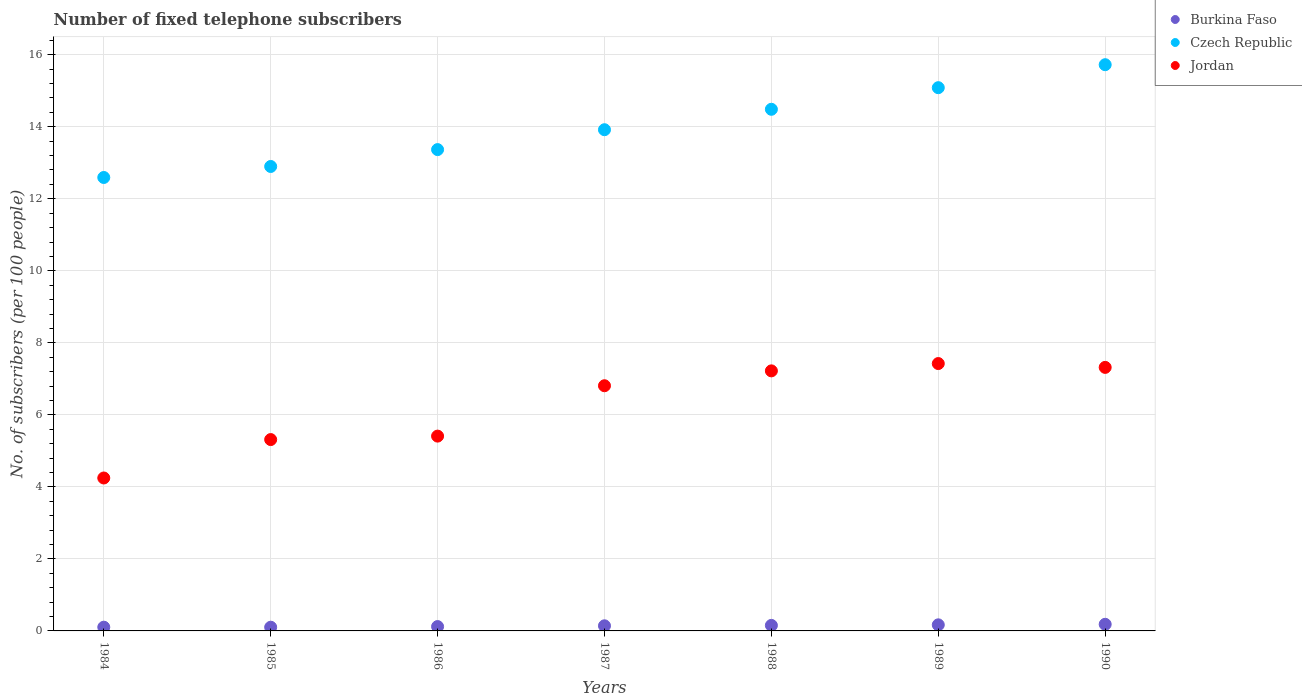How many different coloured dotlines are there?
Your answer should be compact. 3. Is the number of dotlines equal to the number of legend labels?
Your answer should be compact. Yes. What is the number of fixed telephone subscribers in Czech Republic in 1985?
Make the answer very short. 12.9. Across all years, what is the maximum number of fixed telephone subscribers in Czech Republic?
Give a very brief answer. 15.72. Across all years, what is the minimum number of fixed telephone subscribers in Jordan?
Provide a succinct answer. 4.25. In which year was the number of fixed telephone subscribers in Czech Republic maximum?
Your answer should be very brief. 1990. What is the total number of fixed telephone subscribers in Jordan in the graph?
Offer a very short reply. 43.74. What is the difference between the number of fixed telephone subscribers in Czech Republic in 1985 and that in 1989?
Provide a short and direct response. -2.19. What is the difference between the number of fixed telephone subscribers in Czech Republic in 1988 and the number of fixed telephone subscribers in Jordan in 1987?
Offer a very short reply. 7.68. What is the average number of fixed telephone subscribers in Burkina Faso per year?
Keep it short and to the point. 0.14. In the year 1990, what is the difference between the number of fixed telephone subscribers in Jordan and number of fixed telephone subscribers in Czech Republic?
Offer a very short reply. -8.41. What is the ratio of the number of fixed telephone subscribers in Burkina Faso in 1989 to that in 1990?
Offer a terse response. 0.92. What is the difference between the highest and the second highest number of fixed telephone subscribers in Jordan?
Provide a succinct answer. 0.11. What is the difference between the highest and the lowest number of fixed telephone subscribers in Czech Republic?
Your answer should be very brief. 3.13. Is the number of fixed telephone subscribers in Burkina Faso strictly greater than the number of fixed telephone subscribers in Jordan over the years?
Make the answer very short. No. How many dotlines are there?
Your answer should be compact. 3. How many years are there in the graph?
Offer a terse response. 7. Does the graph contain any zero values?
Your response must be concise. No. Where does the legend appear in the graph?
Your answer should be compact. Top right. What is the title of the graph?
Your response must be concise. Number of fixed telephone subscribers. What is the label or title of the Y-axis?
Your answer should be compact. No. of subscribers (per 100 people). What is the No. of subscribers (per 100 people) in Burkina Faso in 1984?
Provide a short and direct response. 0.1. What is the No. of subscribers (per 100 people) in Czech Republic in 1984?
Offer a very short reply. 12.59. What is the No. of subscribers (per 100 people) in Jordan in 1984?
Ensure brevity in your answer.  4.25. What is the No. of subscribers (per 100 people) of Burkina Faso in 1985?
Make the answer very short. 0.1. What is the No. of subscribers (per 100 people) of Czech Republic in 1985?
Provide a succinct answer. 12.9. What is the No. of subscribers (per 100 people) in Jordan in 1985?
Provide a succinct answer. 5.31. What is the No. of subscribers (per 100 people) in Burkina Faso in 1986?
Give a very brief answer. 0.12. What is the No. of subscribers (per 100 people) of Czech Republic in 1986?
Your answer should be very brief. 13.37. What is the No. of subscribers (per 100 people) of Jordan in 1986?
Ensure brevity in your answer.  5.41. What is the No. of subscribers (per 100 people) in Burkina Faso in 1987?
Your response must be concise. 0.14. What is the No. of subscribers (per 100 people) in Czech Republic in 1987?
Your answer should be very brief. 13.92. What is the No. of subscribers (per 100 people) in Jordan in 1987?
Your answer should be compact. 6.81. What is the No. of subscribers (per 100 people) in Burkina Faso in 1988?
Your response must be concise. 0.15. What is the No. of subscribers (per 100 people) of Czech Republic in 1988?
Ensure brevity in your answer.  14.49. What is the No. of subscribers (per 100 people) in Jordan in 1988?
Keep it short and to the point. 7.22. What is the No. of subscribers (per 100 people) of Burkina Faso in 1989?
Make the answer very short. 0.17. What is the No. of subscribers (per 100 people) in Czech Republic in 1989?
Your answer should be very brief. 15.09. What is the No. of subscribers (per 100 people) in Jordan in 1989?
Your answer should be compact. 7.42. What is the No. of subscribers (per 100 people) of Burkina Faso in 1990?
Your response must be concise. 0.18. What is the No. of subscribers (per 100 people) in Czech Republic in 1990?
Provide a succinct answer. 15.72. What is the No. of subscribers (per 100 people) in Jordan in 1990?
Offer a terse response. 7.32. Across all years, what is the maximum No. of subscribers (per 100 people) in Burkina Faso?
Keep it short and to the point. 0.18. Across all years, what is the maximum No. of subscribers (per 100 people) of Czech Republic?
Make the answer very short. 15.72. Across all years, what is the maximum No. of subscribers (per 100 people) in Jordan?
Ensure brevity in your answer.  7.42. Across all years, what is the minimum No. of subscribers (per 100 people) in Burkina Faso?
Make the answer very short. 0.1. Across all years, what is the minimum No. of subscribers (per 100 people) of Czech Republic?
Give a very brief answer. 12.59. Across all years, what is the minimum No. of subscribers (per 100 people) in Jordan?
Ensure brevity in your answer.  4.25. What is the total No. of subscribers (per 100 people) in Czech Republic in the graph?
Your response must be concise. 98.07. What is the total No. of subscribers (per 100 people) of Jordan in the graph?
Keep it short and to the point. 43.74. What is the difference between the No. of subscribers (per 100 people) of Burkina Faso in 1984 and that in 1985?
Offer a very short reply. 0. What is the difference between the No. of subscribers (per 100 people) in Czech Republic in 1984 and that in 1985?
Your answer should be compact. -0.31. What is the difference between the No. of subscribers (per 100 people) in Jordan in 1984 and that in 1985?
Provide a short and direct response. -1.07. What is the difference between the No. of subscribers (per 100 people) in Burkina Faso in 1984 and that in 1986?
Give a very brief answer. -0.02. What is the difference between the No. of subscribers (per 100 people) in Czech Republic in 1984 and that in 1986?
Provide a succinct answer. -0.77. What is the difference between the No. of subscribers (per 100 people) in Jordan in 1984 and that in 1986?
Give a very brief answer. -1.16. What is the difference between the No. of subscribers (per 100 people) of Burkina Faso in 1984 and that in 1987?
Make the answer very short. -0.04. What is the difference between the No. of subscribers (per 100 people) of Czech Republic in 1984 and that in 1987?
Offer a terse response. -1.33. What is the difference between the No. of subscribers (per 100 people) in Jordan in 1984 and that in 1987?
Your response must be concise. -2.56. What is the difference between the No. of subscribers (per 100 people) in Burkina Faso in 1984 and that in 1988?
Provide a short and direct response. -0.05. What is the difference between the No. of subscribers (per 100 people) of Czech Republic in 1984 and that in 1988?
Provide a succinct answer. -1.89. What is the difference between the No. of subscribers (per 100 people) of Jordan in 1984 and that in 1988?
Your response must be concise. -2.97. What is the difference between the No. of subscribers (per 100 people) in Burkina Faso in 1984 and that in 1989?
Your answer should be very brief. -0.07. What is the difference between the No. of subscribers (per 100 people) in Czech Republic in 1984 and that in 1989?
Offer a terse response. -2.49. What is the difference between the No. of subscribers (per 100 people) of Jordan in 1984 and that in 1989?
Ensure brevity in your answer.  -3.18. What is the difference between the No. of subscribers (per 100 people) of Burkina Faso in 1984 and that in 1990?
Provide a short and direct response. -0.08. What is the difference between the No. of subscribers (per 100 people) in Czech Republic in 1984 and that in 1990?
Offer a very short reply. -3.13. What is the difference between the No. of subscribers (per 100 people) in Jordan in 1984 and that in 1990?
Your answer should be very brief. -3.07. What is the difference between the No. of subscribers (per 100 people) in Burkina Faso in 1985 and that in 1986?
Offer a terse response. -0.02. What is the difference between the No. of subscribers (per 100 people) of Czech Republic in 1985 and that in 1986?
Offer a very short reply. -0.47. What is the difference between the No. of subscribers (per 100 people) in Jordan in 1985 and that in 1986?
Provide a short and direct response. -0.1. What is the difference between the No. of subscribers (per 100 people) of Burkina Faso in 1985 and that in 1987?
Provide a succinct answer. -0.04. What is the difference between the No. of subscribers (per 100 people) of Czech Republic in 1985 and that in 1987?
Your answer should be very brief. -1.02. What is the difference between the No. of subscribers (per 100 people) of Jordan in 1985 and that in 1987?
Provide a short and direct response. -1.5. What is the difference between the No. of subscribers (per 100 people) of Burkina Faso in 1985 and that in 1988?
Provide a short and direct response. -0.05. What is the difference between the No. of subscribers (per 100 people) of Czech Republic in 1985 and that in 1988?
Give a very brief answer. -1.59. What is the difference between the No. of subscribers (per 100 people) in Jordan in 1985 and that in 1988?
Keep it short and to the point. -1.91. What is the difference between the No. of subscribers (per 100 people) in Burkina Faso in 1985 and that in 1989?
Your answer should be very brief. -0.07. What is the difference between the No. of subscribers (per 100 people) of Czech Republic in 1985 and that in 1989?
Make the answer very short. -2.19. What is the difference between the No. of subscribers (per 100 people) in Jordan in 1985 and that in 1989?
Make the answer very short. -2.11. What is the difference between the No. of subscribers (per 100 people) of Burkina Faso in 1985 and that in 1990?
Ensure brevity in your answer.  -0.08. What is the difference between the No. of subscribers (per 100 people) in Czech Republic in 1985 and that in 1990?
Your response must be concise. -2.83. What is the difference between the No. of subscribers (per 100 people) of Jordan in 1985 and that in 1990?
Offer a very short reply. -2. What is the difference between the No. of subscribers (per 100 people) of Burkina Faso in 1986 and that in 1987?
Your response must be concise. -0.02. What is the difference between the No. of subscribers (per 100 people) in Czech Republic in 1986 and that in 1987?
Your answer should be very brief. -0.55. What is the difference between the No. of subscribers (per 100 people) in Jordan in 1986 and that in 1987?
Provide a short and direct response. -1.4. What is the difference between the No. of subscribers (per 100 people) in Burkina Faso in 1986 and that in 1988?
Give a very brief answer. -0.03. What is the difference between the No. of subscribers (per 100 people) of Czech Republic in 1986 and that in 1988?
Your answer should be compact. -1.12. What is the difference between the No. of subscribers (per 100 people) in Jordan in 1986 and that in 1988?
Provide a succinct answer. -1.81. What is the difference between the No. of subscribers (per 100 people) of Burkina Faso in 1986 and that in 1989?
Offer a terse response. -0.05. What is the difference between the No. of subscribers (per 100 people) of Czech Republic in 1986 and that in 1989?
Your response must be concise. -1.72. What is the difference between the No. of subscribers (per 100 people) of Jordan in 1986 and that in 1989?
Keep it short and to the point. -2.01. What is the difference between the No. of subscribers (per 100 people) in Burkina Faso in 1986 and that in 1990?
Give a very brief answer. -0.06. What is the difference between the No. of subscribers (per 100 people) in Czech Republic in 1986 and that in 1990?
Provide a succinct answer. -2.36. What is the difference between the No. of subscribers (per 100 people) of Jordan in 1986 and that in 1990?
Offer a very short reply. -1.91. What is the difference between the No. of subscribers (per 100 people) of Burkina Faso in 1987 and that in 1988?
Ensure brevity in your answer.  -0.01. What is the difference between the No. of subscribers (per 100 people) in Czech Republic in 1987 and that in 1988?
Ensure brevity in your answer.  -0.57. What is the difference between the No. of subscribers (per 100 people) in Jordan in 1987 and that in 1988?
Your answer should be compact. -0.41. What is the difference between the No. of subscribers (per 100 people) of Burkina Faso in 1987 and that in 1989?
Provide a succinct answer. -0.03. What is the difference between the No. of subscribers (per 100 people) in Czech Republic in 1987 and that in 1989?
Your response must be concise. -1.17. What is the difference between the No. of subscribers (per 100 people) in Jordan in 1987 and that in 1989?
Ensure brevity in your answer.  -0.62. What is the difference between the No. of subscribers (per 100 people) in Burkina Faso in 1987 and that in 1990?
Offer a very short reply. -0.04. What is the difference between the No. of subscribers (per 100 people) of Czech Republic in 1987 and that in 1990?
Give a very brief answer. -1.81. What is the difference between the No. of subscribers (per 100 people) in Jordan in 1987 and that in 1990?
Give a very brief answer. -0.51. What is the difference between the No. of subscribers (per 100 people) in Burkina Faso in 1988 and that in 1989?
Your answer should be compact. -0.02. What is the difference between the No. of subscribers (per 100 people) of Jordan in 1988 and that in 1989?
Your answer should be very brief. -0.2. What is the difference between the No. of subscribers (per 100 people) of Burkina Faso in 1988 and that in 1990?
Your answer should be compact. -0.03. What is the difference between the No. of subscribers (per 100 people) in Czech Republic in 1988 and that in 1990?
Your answer should be very brief. -1.24. What is the difference between the No. of subscribers (per 100 people) of Jordan in 1988 and that in 1990?
Provide a short and direct response. -0.1. What is the difference between the No. of subscribers (per 100 people) of Burkina Faso in 1989 and that in 1990?
Give a very brief answer. -0.01. What is the difference between the No. of subscribers (per 100 people) of Czech Republic in 1989 and that in 1990?
Offer a terse response. -0.64. What is the difference between the No. of subscribers (per 100 people) in Jordan in 1989 and that in 1990?
Make the answer very short. 0.11. What is the difference between the No. of subscribers (per 100 people) of Burkina Faso in 1984 and the No. of subscribers (per 100 people) of Czech Republic in 1985?
Your response must be concise. -12.79. What is the difference between the No. of subscribers (per 100 people) in Burkina Faso in 1984 and the No. of subscribers (per 100 people) in Jordan in 1985?
Provide a short and direct response. -5.21. What is the difference between the No. of subscribers (per 100 people) in Czech Republic in 1984 and the No. of subscribers (per 100 people) in Jordan in 1985?
Keep it short and to the point. 7.28. What is the difference between the No. of subscribers (per 100 people) of Burkina Faso in 1984 and the No. of subscribers (per 100 people) of Czech Republic in 1986?
Offer a terse response. -13.26. What is the difference between the No. of subscribers (per 100 people) of Burkina Faso in 1984 and the No. of subscribers (per 100 people) of Jordan in 1986?
Offer a terse response. -5.31. What is the difference between the No. of subscribers (per 100 people) of Czech Republic in 1984 and the No. of subscribers (per 100 people) of Jordan in 1986?
Give a very brief answer. 7.18. What is the difference between the No. of subscribers (per 100 people) of Burkina Faso in 1984 and the No. of subscribers (per 100 people) of Czech Republic in 1987?
Make the answer very short. -13.81. What is the difference between the No. of subscribers (per 100 people) of Burkina Faso in 1984 and the No. of subscribers (per 100 people) of Jordan in 1987?
Ensure brevity in your answer.  -6.71. What is the difference between the No. of subscribers (per 100 people) of Czech Republic in 1984 and the No. of subscribers (per 100 people) of Jordan in 1987?
Your response must be concise. 5.78. What is the difference between the No. of subscribers (per 100 people) of Burkina Faso in 1984 and the No. of subscribers (per 100 people) of Czech Republic in 1988?
Provide a short and direct response. -14.38. What is the difference between the No. of subscribers (per 100 people) in Burkina Faso in 1984 and the No. of subscribers (per 100 people) in Jordan in 1988?
Ensure brevity in your answer.  -7.12. What is the difference between the No. of subscribers (per 100 people) in Czech Republic in 1984 and the No. of subscribers (per 100 people) in Jordan in 1988?
Your answer should be very brief. 5.37. What is the difference between the No. of subscribers (per 100 people) in Burkina Faso in 1984 and the No. of subscribers (per 100 people) in Czech Republic in 1989?
Your answer should be compact. -14.98. What is the difference between the No. of subscribers (per 100 people) in Burkina Faso in 1984 and the No. of subscribers (per 100 people) in Jordan in 1989?
Make the answer very short. -7.32. What is the difference between the No. of subscribers (per 100 people) of Czech Republic in 1984 and the No. of subscribers (per 100 people) of Jordan in 1989?
Give a very brief answer. 5.17. What is the difference between the No. of subscribers (per 100 people) of Burkina Faso in 1984 and the No. of subscribers (per 100 people) of Czech Republic in 1990?
Make the answer very short. -15.62. What is the difference between the No. of subscribers (per 100 people) in Burkina Faso in 1984 and the No. of subscribers (per 100 people) in Jordan in 1990?
Offer a terse response. -7.21. What is the difference between the No. of subscribers (per 100 people) in Czech Republic in 1984 and the No. of subscribers (per 100 people) in Jordan in 1990?
Offer a very short reply. 5.27. What is the difference between the No. of subscribers (per 100 people) of Burkina Faso in 1985 and the No. of subscribers (per 100 people) of Czech Republic in 1986?
Your answer should be very brief. -13.26. What is the difference between the No. of subscribers (per 100 people) in Burkina Faso in 1985 and the No. of subscribers (per 100 people) in Jordan in 1986?
Offer a terse response. -5.31. What is the difference between the No. of subscribers (per 100 people) in Czech Republic in 1985 and the No. of subscribers (per 100 people) in Jordan in 1986?
Ensure brevity in your answer.  7.49. What is the difference between the No. of subscribers (per 100 people) of Burkina Faso in 1985 and the No. of subscribers (per 100 people) of Czech Republic in 1987?
Ensure brevity in your answer.  -13.82. What is the difference between the No. of subscribers (per 100 people) of Burkina Faso in 1985 and the No. of subscribers (per 100 people) of Jordan in 1987?
Keep it short and to the point. -6.71. What is the difference between the No. of subscribers (per 100 people) in Czech Republic in 1985 and the No. of subscribers (per 100 people) in Jordan in 1987?
Give a very brief answer. 6.09. What is the difference between the No. of subscribers (per 100 people) in Burkina Faso in 1985 and the No. of subscribers (per 100 people) in Czech Republic in 1988?
Offer a very short reply. -14.38. What is the difference between the No. of subscribers (per 100 people) in Burkina Faso in 1985 and the No. of subscribers (per 100 people) in Jordan in 1988?
Keep it short and to the point. -7.12. What is the difference between the No. of subscribers (per 100 people) in Czech Republic in 1985 and the No. of subscribers (per 100 people) in Jordan in 1988?
Offer a very short reply. 5.68. What is the difference between the No. of subscribers (per 100 people) of Burkina Faso in 1985 and the No. of subscribers (per 100 people) of Czech Republic in 1989?
Your response must be concise. -14.98. What is the difference between the No. of subscribers (per 100 people) in Burkina Faso in 1985 and the No. of subscribers (per 100 people) in Jordan in 1989?
Your answer should be compact. -7.32. What is the difference between the No. of subscribers (per 100 people) of Czech Republic in 1985 and the No. of subscribers (per 100 people) of Jordan in 1989?
Provide a succinct answer. 5.47. What is the difference between the No. of subscribers (per 100 people) in Burkina Faso in 1985 and the No. of subscribers (per 100 people) in Czech Republic in 1990?
Provide a succinct answer. -15.62. What is the difference between the No. of subscribers (per 100 people) in Burkina Faso in 1985 and the No. of subscribers (per 100 people) in Jordan in 1990?
Offer a terse response. -7.22. What is the difference between the No. of subscribers (per 100 people) of Czech Republic in 1985 and the No. of subscribers (per 100 people) of Jordan in 1990?
Your answer should be compact. 5.58. What is the difference between the No. of subscribers (per 100 people) of Burkina Faso in 1986 and the No. of subscribers (per 100 people) of Czech Republic in 1987?
Your answer should be very brief. -13.8. What is the difference between the No. of subscribers (per 100 people) of Burkina Faso in 1986 and the No. of subscribers (per 100 people) of Jordan in 1987?
Offer a terse response. -6.69. What is the difference between the No. of subscribers (per 100 people) of Czech Republic in 1986 and the No. of subscribers (per 100 people) of Jordan in 1987?
Your answer should be very brief. 6.56. What is the difference between the No. of subscribers (per 100 people) in Burkina Faso in 1986 and the No. of subscribers (per 100 people) in Czech Republic in 1988?
Your answer should be compact. -14.36. What is the difference between the No. of subscribers (per 100 people) of Burkina Faso in 1986 and the No. of subscribers (per 100 people) of Jordan in 1988?
Provide a short and direct response. -7.1. What is the difference between the No. of subscribers (per 100 people) of Czech Republic in 1986 and the No. of subscribers (per 100 people) of Jordan in 1988?
Your response must be concise. 6.14. What is the difference between the No. of subscribers (per 100 people) in Burkina Faso in 1986 and the No. of subscribers (per 100 people) in Czech Republic in 1989?
Keep it short and to the point. -14.96. What is the difference between the No. of subscribers (per 100 people) of Burkina Faso in 1986 and the No. of subscribers (per 100 people) of Jordan in 1989?
Ensure brevity in your answer.  -7.3. What is the difference between the No. of subscribers (per 100 people) of Czech Republic in 1986 and the No. of subscribers (per 100 people) of Jordan in 1989?
Your answer should be very brief. 5.94. What is the difference between the No. of subscribers (per 100 people) of Burkina Faso in 1986 and the No. of subscribers (per 100 people) of Czech Republic in 1990?
Provide a succinct answer. -15.6. What is the difference between the No. of subscribers (per 100 people) in Burkina Faso in 1986 and the No. of subscribers (per 100 people) in Jordan in 1990?
Offer a very short reply. -7.2. What is the difference between the No. of subscribers (per 100 people) in Czech Republic in 1986 and the No. of subscribers (per 100 people) in Jordan in 1990?
Keep it short and to the point. 6.05. What is the difference between the No. of subscribers (per 100 people) of Burkina Faso in 1987 and the No. of subscribers (per 100 people) of Czech Republic in 1988?
Give a very brief answer. -14.34. What is the difference between the No. of subscribers (per 100 people) of Burkina Faso in 1987 and the No. of subscribers (per 100 people) of Jordan in 1988?
Offer a very short reply. -7.08. What is the difference between the No. of subscribers (per 100 people) in Czech Republic in 1987 and the No. of subscribers (per 100 people) in Jordan in 1988?
Provide a succinct answer. 6.7. What is the difference between the No. of subscribers (per 100 people) in Burkina Faso in 1987 and the No. of subscribers (per 100 people) in Czech Republic in 1989?
Keep it short and to the point. -14.94. What is the difference between the No. of subscribers (per 100 people) of Burkina Faso in 1987 and the No. of subscribers (per 100 people) of Jordan in 1989?
Provide a succinct answer. -7.28. What is the difference between the No. of subscribers (per 100 people) in Czech Republic in 1987 and the No. of subscribers (per 100 people) in Jordan in 1989?
Your answer should be compact. 6.49. What is the difference between the No. of subscribers (per 100 people) of Burkina Faso in 1987 and the No. of subscribers (per 100 people) of Czech Republic in 1990?
Provide a short and direct response. -15.58. What is the difference between the No. of subscribers (per 100 people) in Burkina Faso in 1987 and the No. of subscribers (per 100 people) in Jordan in 1990?
Offer a terse response. -7.18. What is the difference between the No. of subscribers (per 100 people) of Burkina Faso in 1988 and the No. of subscribers (per 100 people) of Czech Republic in 1989?
Offer a very short reply. -14.93. What is the difference between the No. of subscribers (per 100 people) in Burkina Faso in 1988 and the No. of subscribers (per 100 people) in Jordan in 1989?
Provide a succinct answer. -7.27. What is the difference between the No. of subscribers (per 100 people) in Czech Republic in 1988 and the No. of subscribers (per 100 people) in Jordan in 1989?
Your answer should be compact. 7.06. What is the difference between the No. of subscribers (per 100 people) of Burkina Faso in 1988 and the No. of subscribers (per 100 people) of Czech Republic in 1990?
Your answer should be compact. -15.57. What is the difference between the No. of subscribers (per 100 people) of Burkina Faso in 1988 and the No. of subscribers (per 100 people) of Jordan in 1990?
Give a very brief answer. -7.17. What is the difference between the No. of subscribers (per 100 people) in Czech Republic in 1988 and the No. of subscribers (per 100 people) in Jordan in 1990?
Provide a short and direct response. 7.17. What is the difference between the No. of subscribers (per 100 people) of Burkina Faso in 1989 and the No. of subscribers (per 100 people) of Czech Republic in 1990?
Your answer should be very brief. -15.55. What is the difference between the No. of subscribers (per 100 people) in Burkina Faso in 1989 and the No. of subscribers (per 100 people) in Jordan in 1990?
Make the answer very short. -7.15. What is the difference between the No. of subscribers (per 100 people) of Czech Republic in 1989 and the No. of subscribers (per 100 people) of Jordan in 1990?
Ensure brevity in your answer.  7.77. What is the average No. of subscribers (per 100 people) in Burkina Faso per year?
Make the answer very short. 0.14. What is the average No. of subscribers (per 100 people) of Czech Republic per year?
Offer a terse response. 14.01. What is the average No. of subscribers (per 100 people) in Jordan per year?
Give a very brief answer. 6.25. In the year 1984, what is the difference between the No. of subscribers (per 100 people) of Burkina Faso and No. of subscribers (per 100 people) of Czech Republic?
Your answer should be very brief. -12.49. In the year 1984, what is the difference between the No. of subscribers (per 100 people) of Burkina Faso and No. of subscribers (per 100 people) of Jordan?
Keep it short and to the point. -4.14. In the year 1984, what is the difference between the No. of subscribers (per 100 people) in Czech Republic and No. of subscribers (per 100 people) in Jordan?
Your response must be concise. 8.35. In the year 1985, what is the difference between the No. of subscribers (per 100 people) in Burkina Faso and No. of subscribers (per 100 people) in Czech Republic?
Provide a short and direct response. -12.79. In the year 1985, what is the difference between the No. of subscribers (per 100 people) of Burkina Faso and No. of subscribers (per 100 people) of Jordan?
Your answer should be very brief. -5.21. In the year 1985, what is the difference between the No. of subscribers (per 100 people) in Czech Republic and No. of subscribers (per 100 people) in Jordan?
Ensure brevity in your answer.  7.58. In the year 1986, what is the difference between the No. of subscribers (per 100 people) of Burkina Faso and No. of subscribers (per 100 people) of Czech Republic?
Offer a terse response. -13.25. In the year 1986, what is the difference between the No. of subscribers (per 100 people) of Burkina Faso and No. of subscribers (per 100 people) of Jordan?
Your answer should be very brief. -5.29. In the year 1986, what is the difference between the No. of subscribers (per 100 people) of Czech Republic and No. of subscribers (per 100 people) of Jordan?
Your response must be concise. 7.96. In the year 1987, what is the difference between the No. of subscribers (per 100 people) of Burkina Faso and No. of subscribers (per 100 people) of Czech Republic?
Offer a very short reply. -13.78. In the year 1987, what is the difference between the No. of subscribers (per 100 people) in Burkina Faso and No. of subscribers (per 100 people) in Jordan?
Ensure brevity in your answer.  -6.67. In the year 1987, what is the difference between the No. of subscribers (per 100 people) in Czech Republic and No. of subscribers (per 100 people) in Jordan?
Keep it short and to the point. 7.11. In the year 1988, what is the difference between the No. of subscribers (per 100 people) of Burkina Faso and No. of subscribers (per 100 people) of Czech Republic?
Keep it short and to the point. -14.33. In the year 1988, what is the difference between the No. of subscribers (per 100 people) of Burkina Faso and No. of subscribers (per 100 people) of Jordan?
Make the answer very short. -7.07. In the year 1988, what is the difference between the No. of subscribers (per 100 people) in Czech Republic and No. of subscribers (per 100 people) in Jordan?
Your answer should be very brief. 7.26. In the year 1989, what is the difference between the No. of subscribers (per 100 people) of Burkina Faso and No. of subscribers (per 100 people) of Czech Republic?
Provide a short and direct response. -14.92. In the year 1989, what is the difference between the No. of subscribers (per 100 people) in Burkina Faso and No. of subscribers (per 100 people) in Jordan?
Keep it short and to the point. -7.26. In the year 1989, what is the difference between the No. of subscribers (per 100 people) in Czech Republic and No. of subscribers (per 100 people) in Jordan?
Give a very brief answer. 7.66. In the year 1990, what is the difference between the No. of subscribers (per 100 people) in Burkina Faso and No. of subscribers (per 100 people) in Czech Republic?
Provide a short and direct response. -15.54. In the year 1990, what is the difference between the No. of subscribers (per 100 people) in Burkina Faso and No. of subscribers (per 100 people) in Jordan?
Offer a very short reply. -7.13. In the year 1990, what is the difference between the No. of subscribers (per 100 people) of Czech Republic and No. of subscribers (per 100 people) of Jordan?
Provide a succinct answer. 8.41. What is the ratio of the No. of subscribers (per 100 people) in Burkina Faso in 1984 to that in 1985?
Provide a succinct answer. 1.01. What is the ratio of the No. of subscribers (per 100 people) in Czech Republic in 1984 to that in 1985?
Provide a succinct answer. 0.98. What is the ratio of the No. of subscribers (per 100 people) of Jordan in 1984 to that in 1985?
Your response must be concise. 0.8. What is the ratio of the No. of subscribers (per 100 people) of Burkina Faso in 1984 to that in 1986?
Keep it short and to the point. 0.86. What is the ratio of the No. of subscribers (per 100 people) in Czech Republic in 1984 to that in 1986?
Give a very brief answer. 0.94. What is the ratio of the No. of subscribers (per 100 people) of Jordan in 1984 to that in 1986?
Make the answer very short. 0.79. What is the ratio of the No. of subscribers (per 100 people) of Burkina Faso in 1984 to that in 1987?
Provide a short and direct response. 0.73. What is the ratio of the No. of subscribers (per 100 people) of Czech Republic in 1984 to that in 1987?
Your response must be concise. 0.9. What is the ratio of the No. of subscribers (per 100 people) of Jordan in 1984 to that in 1987?
Your answer should be very brief. 0.62. What is the ratio of the No. of subscribers (per 100 people) in Burkina Faso in 1984 to that in 1988?
Provide a succinct answer. 0.68. What is the ratio of the No. of subscribers (per 100 people) of Czech Republic in 1984 to that in 1988?
Ensure brevity in your answer.  0.87. What is the ratio of the No. of subscribers (per 100 people) in Jordan in 1984 to that in 1988?
Your response must be concise. 0.59. What is the ratio of the No. of subscribers (per 100 people) in Burkina Faso in 1984 to that in 1989?
Give a very brief answer. 0.61. What is the ratio of the No. of subscribers (per 100 people) in Czech Republic in 1984 to that in 1989?
Your response must be concise. 0.83. What is the ratio of the No. of subscribers (per 100 people) in Jordan in 1984 to that in 1989?
Offer a very short reply. 0.57. What is the ratio of the No. of subscribers (per 100 people) of Burkina Faso in 1984 to that in 1990?
Your answer should be compact. 0.56. What is the ratio of the No. of subscribers (per 100 people) of Czech Republic in 1984 to that in 1990?
Keep it short and to the point. 0.8. What is the ratio of the No. of subscribers (per 100 people) of Jordan in 1984 to that in 1990?
Ensure brevity in your answer.  0.58. What is the ratio of the No. of subscribers (per 100 people) of Burkina Faso in 1985 to that in 1986?
Give a very brief answer. 0.85. What is the ratio of the No. of subscribers (per 100 people) of Czech Republic in 1985 to that in 1986?
Your answer should be very brief. 0.96. What is the ratio of the No. of subscribers (per 100 people) of Jordan in 1985 to that in 1986?
Your answer should be very brief. 0.98. What is the ratio of the No. of subscribers (per 100 people) in Burkina Faso in 1985 to that in 1987?
Offer a very short reply. 0.72. What is the ratio of the No. of subscribers (per 100 people) of Czech Republic in 1985 to that in 1987?
Your answer should be very brief. 0.93. What is the ratio of the No. of subscribers (per 100 people) in Jordan in 1985 to that in 1987?
Offer a terse response. 0.78. What is the ratio of the No. of subscribers (per 100 people) of Burkina Faso in 1985 to that in 1988?
Your answer should be very brief. 0.67. What is the ratio of the No. of subscribers (per 100 people) of Czech Republic in 1985 to that in 1988?
Your response must be concise. 0.89. What is the ratio of the No. of subscribers (per 100 people) of Jordan in 1985 to that in 1988?
Ensure brevity in your answer.  0.74. What is the ratio of the No. of subscribers (per 100 people) in Burkina Faso in 1985 to that in 1989?
Provide a short and direct response. 0.61. What is the ratio of the No. of subscribers (per 100 people) of Czech Republic in 1985 to that in 1989?
Ensure brevity in your answer.  0.85. What is the ratio of the No. of subscribers (per 100 people) in Jordan in 1985 to that in 1989?
Keep it short and to the point. 0.72. What is the ratio of the No. of subscribers (per 100 people) of Burkina Faso in 1985 to that in 1990?
Ensure brevity in your answer.  0.56. What is the ratio of the No. of subscribers (per 100 people) in Czech Republic in 1985 to that in 1990?
Your answer should be compact. 0.82. What is the ratio of the No. of subscribers (per 100 people) of Jordan in 1985 to that in 1990?
Offer a terse response. 0.73. What is the ratio of the No. of subscribers (per 100 people) of Burkina Faso in 1986 to that in 1987?
Your response must be concise. 0.85. What is the ratio of the No. of subscribers (per 100 people) in Czech Republic in 1986 to that in 1987?
Your response must be concise. 0.96. What is the ratio of the No. of subscribers (per 100 people) in Jordan in 1986 to that in 1987?
Provide a succinct answer. 0.79. What is the ratio of the No. of subscribers (per 100 people) of Burkina Faso in 1986 to that in 1988?
Ensure brevity in your answer.  0.79. What is the ratio of the No. of subscribers (per 100 people) in Czech Republic in 1986 to that in 1988?
Your answer should be very brief. 0.92. What is the ratio of the No. of subscribers (per 100 people) in Jordan in 1986 to that in 1988?
Make the answer very short. 0.75. What is the ratio of the No. of subscribers (per 100 people) in Burkina Faso in 1986 to that in 1989?
Keep it short and to the point. 0.72. What is the ratio of the No. of subscribers (per 100 people) of Czech Republic in 1986 to that in 1989?
Provide a short and direct response. 0.89. What is the ratio of the No. of subscribers (per 100 people) of Jordan in 1986 to that in 1989?
Your answer should be very brief. 0.73. What is the ratio of the No. of subscribers (per 100 people) of Burkina Faso in 1986 to that in 1990?
Provide a succinct answer. 0.66. What is the ratio of the No. of subscribers (per 100 people) of Czech Republic in 1986 to that in 1990?
Make the answer very short. 0.85. What is the ratio of the No. of subscribers (per 100 people) of Jordan in 1986 to that in 1990?
Ensure brevity in your answer.  0.74. What is the ratio of the No. of subscribers (per 100 people) of Burkina Faso in 1987 to that in 1988?
Give a very brief answer. 0.93. What is the ratio of the No. of subscribers (per 100 people) in Czech Republic in 1987 to that in 1988?
Your response must be concise. 0.96. What is the ratio of the No. of subscribers (per 100 people) in Jordan in 1987 to that in 1988?
Provide a succinct answer. 0.94. What is the ratio of the No. of subscribers (per 100 people) of Burkina Faso in 1987 to that in 1989?
Offer a terse response. 0.84. What is the ratio of the No. of subscribers (per 100 people) of Czech Republic in 1987 to that in 1989?
Your answer should be very brief. 0.92. What is the ratio of the No. of subscribers (per 100 people) of Jordan in 1987 to that in 1989?
Your answer should be very brief. 0.92. What is the ratio of the No. of subscribers (per 100 people) in Burkina Faso in 1987 to that in 1990?
Ensure brevity in your answer.  0.77. What is the ratio of the No. of subscribers (per 100 people) in Czech Republic in 1987 to that in 1990?
Give a very brief answer. 0.89. What is the ratio of the No. of subscribers (per 100 people) of Jordan in 1987 to that in 1990?
Your response must be concise. 0.93. What is the ratio of the No. of subscribers (per 100 people) of Burkina Faso in 1988 to that in 1989?
Ensure brevity in your answer.  0.91. What is the ratio of the No. of subscribers (per 100 people) of Czech Republic in 1988 to that in 1989?
Provide a short and direct response. 0.96. What is the ratio of the No. of subscribers (per 100 people) in Jordan in 1988 to that in 1989?
Ensure brevity in your answer.  0.97. What is the ratio of the No. of subscribers (per 100 people) of Burkina Faso in 1988 to that in 1990?
Keep it short and to the point. 0.83. What is the ratio of the No. of subscribers (per 100 people) of Czech Republic in 1988 to that in 1990?
Provide a succinct answer. 0.92. What is the ratio of the No. of subscribers (per 100 people) of Burkina Faso in 1989 to that in 1990?
Keep it short and to the point. 0.92. What is the ratio of the No. of subscribers (per 100 people) in Czech Republic in 1989 to that in 1990?
Offer a very short reply. 0.96. What is the ratio of the No. of subscribers (per 100 people) in Jordan in 1989 to that in 1990?
Your answer should be compact. 1.01. What is the difference between the highest and the second highest No. of subscribers (per 100 people) in Burkina Faso?
Give a very brief answer. 0.01. What is the difference between the highest and the second highest No. of subscribers (per 100 people) of Czech Republic?
Ensure brevity in your answer.  0.64. What is the difference between the highest and the second highest No. of subscribers (per 100 people) in Jordan?
Give a very brief answer. 0.11. What is the difference between the highest and the lowest No. of subscribers (per 100 people) of Burkina Faso?
Your answer should be compact. 0.08. What is the difference between the highest and the lowest No. of subscribers (per 100 people) in Czech Republic?
Provide a succinct answer. 3.13. What is the difference between the highest and the lowest No. of subscribers (per 100 people) of Jordan?
Offer a very short reply. 3.18. 